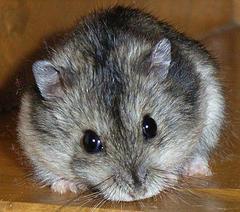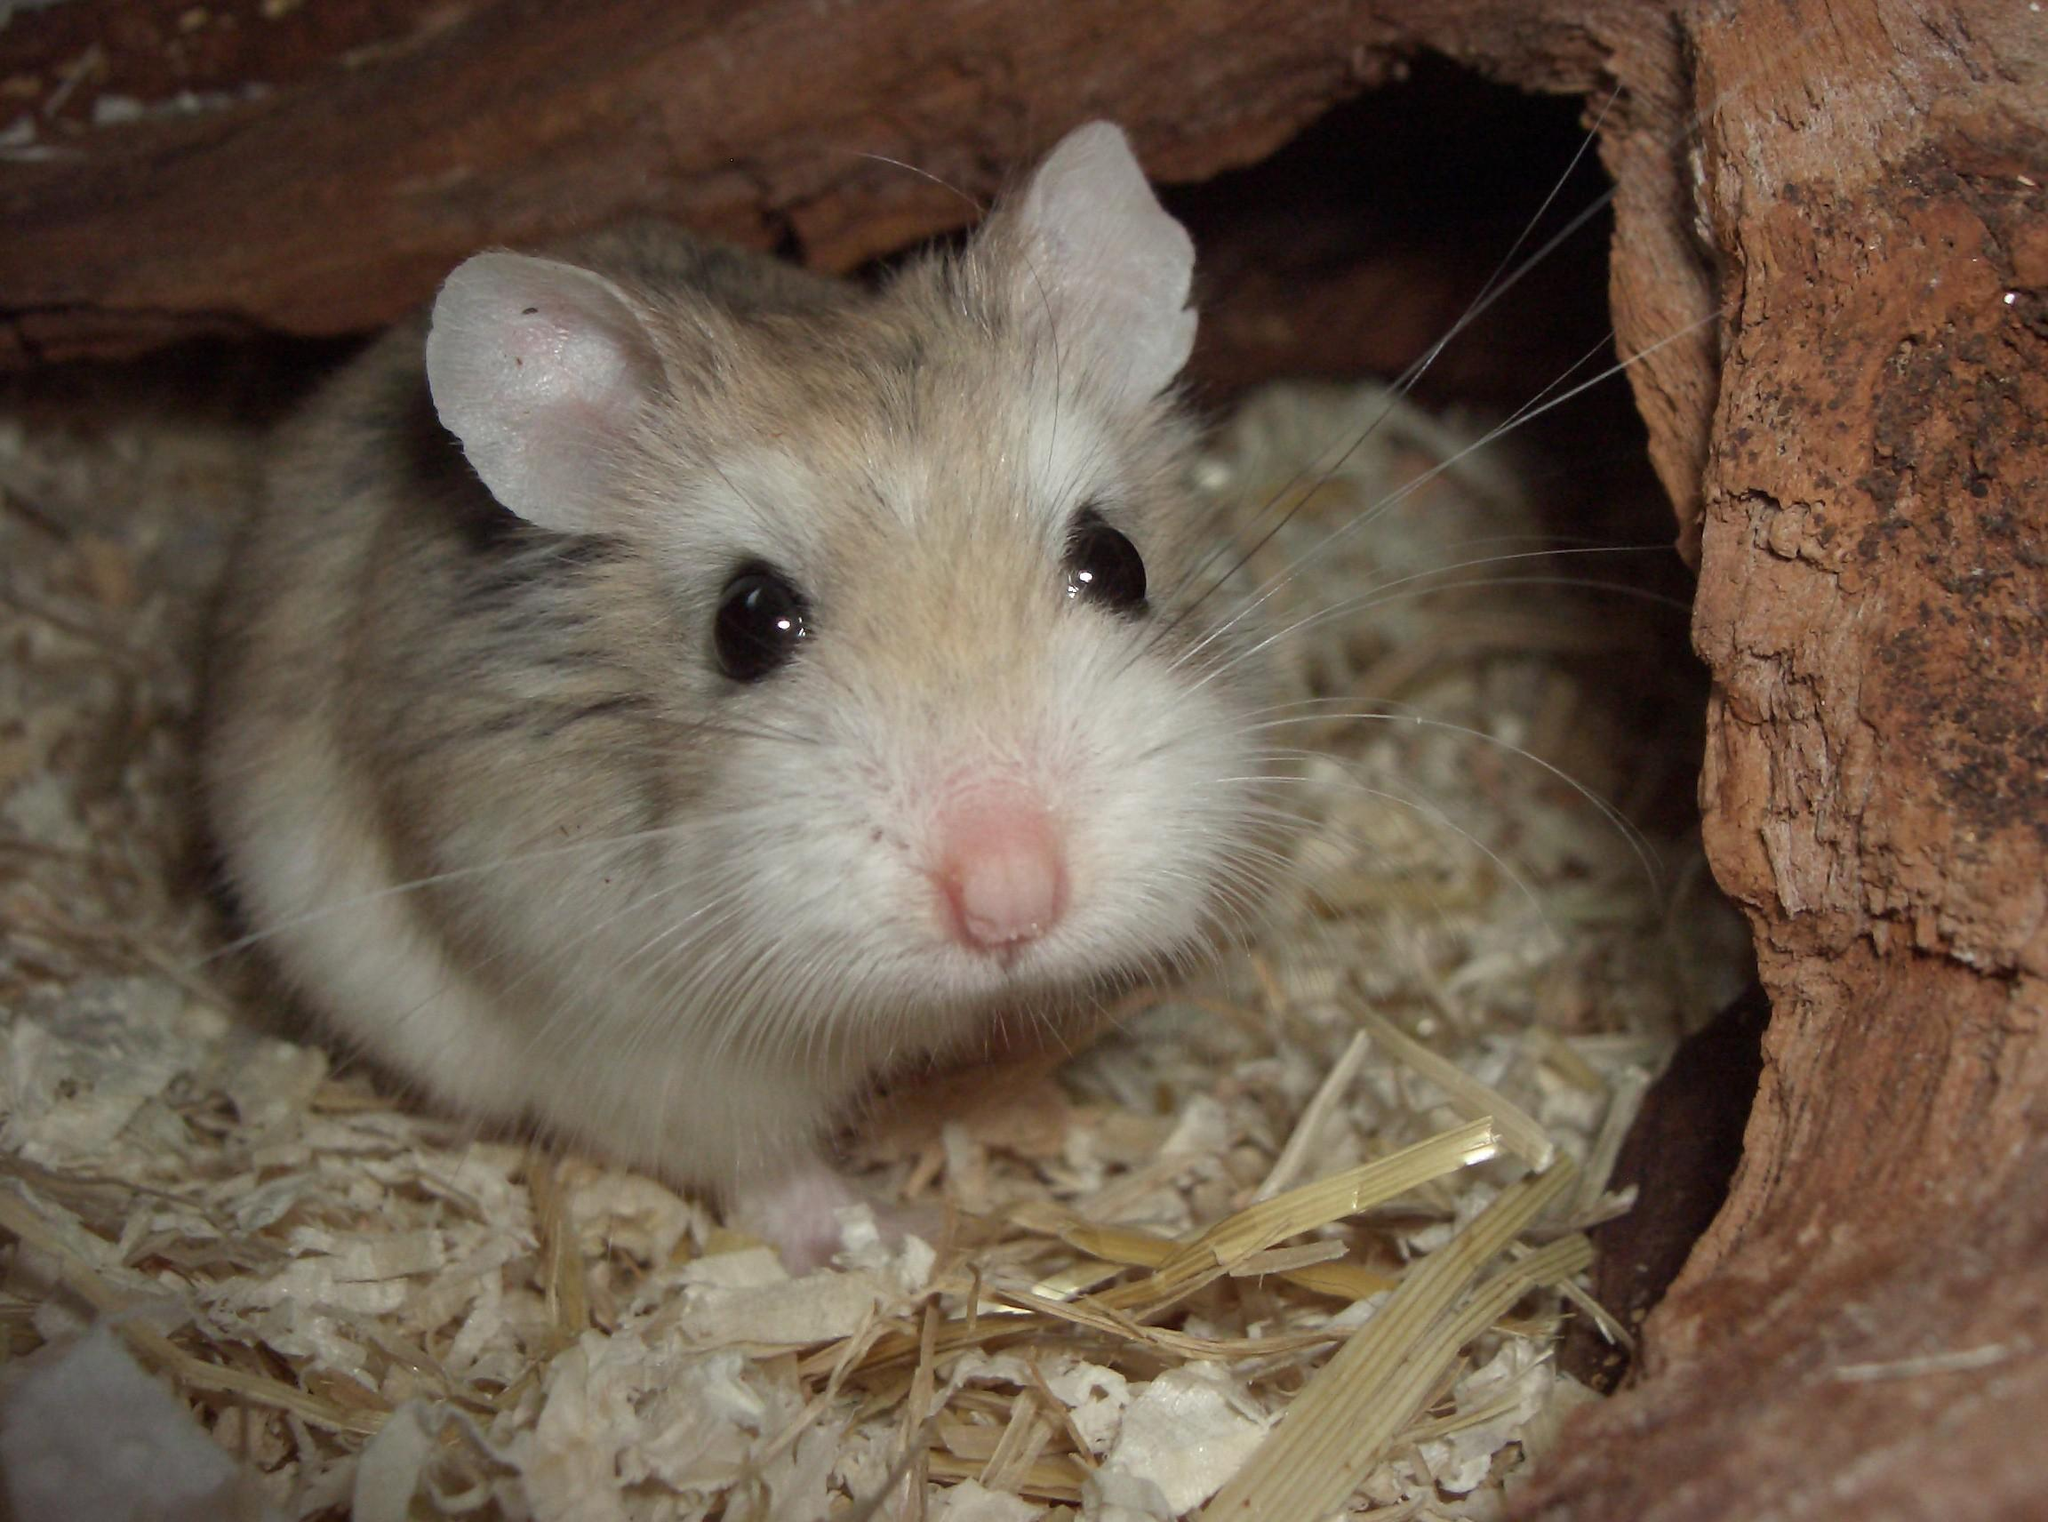The first image is the image on the left, the second image is the image on the right. Evaluate the accuracy of this statement regarding the images: "At least one hamster is sitting on wood shavings.". Is it true? Answer yes or no. Yes. The first image is the image on the left, the second image is the image on the right. Examine the images to the left and right. Is the description "The image pair contains one hamster in the left image and two hamsters in the right image." accurate? Answer yes or no. No. 